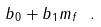<formula> <loc_0><loc_0><loc_500><loc_500>b _ { 0 } + b _ { 1 } m _ { f } \ .</formula> 